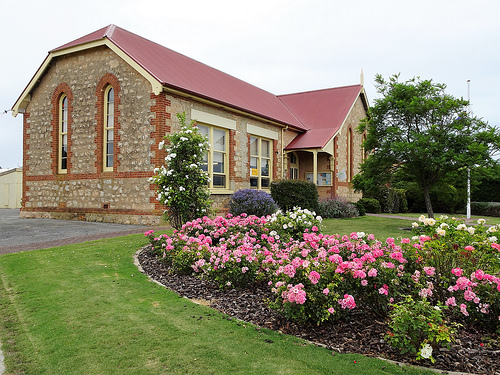<image>
Is there a house behind the flowers? Yes. From this viewpoint, the house is positioned behind the flowers, with the flowers partially or fully occluding the house. 